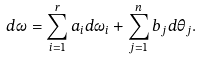<formula> <loc_0><loc_0><loc_500><loc_500>d \omega = \sum _ { i = 1 } ^ { r } a _ { i } d \omega _ { i } + \sum _ { j = 1 } ^ { n } b _ { j } d \theta _ { j } .</formula> 